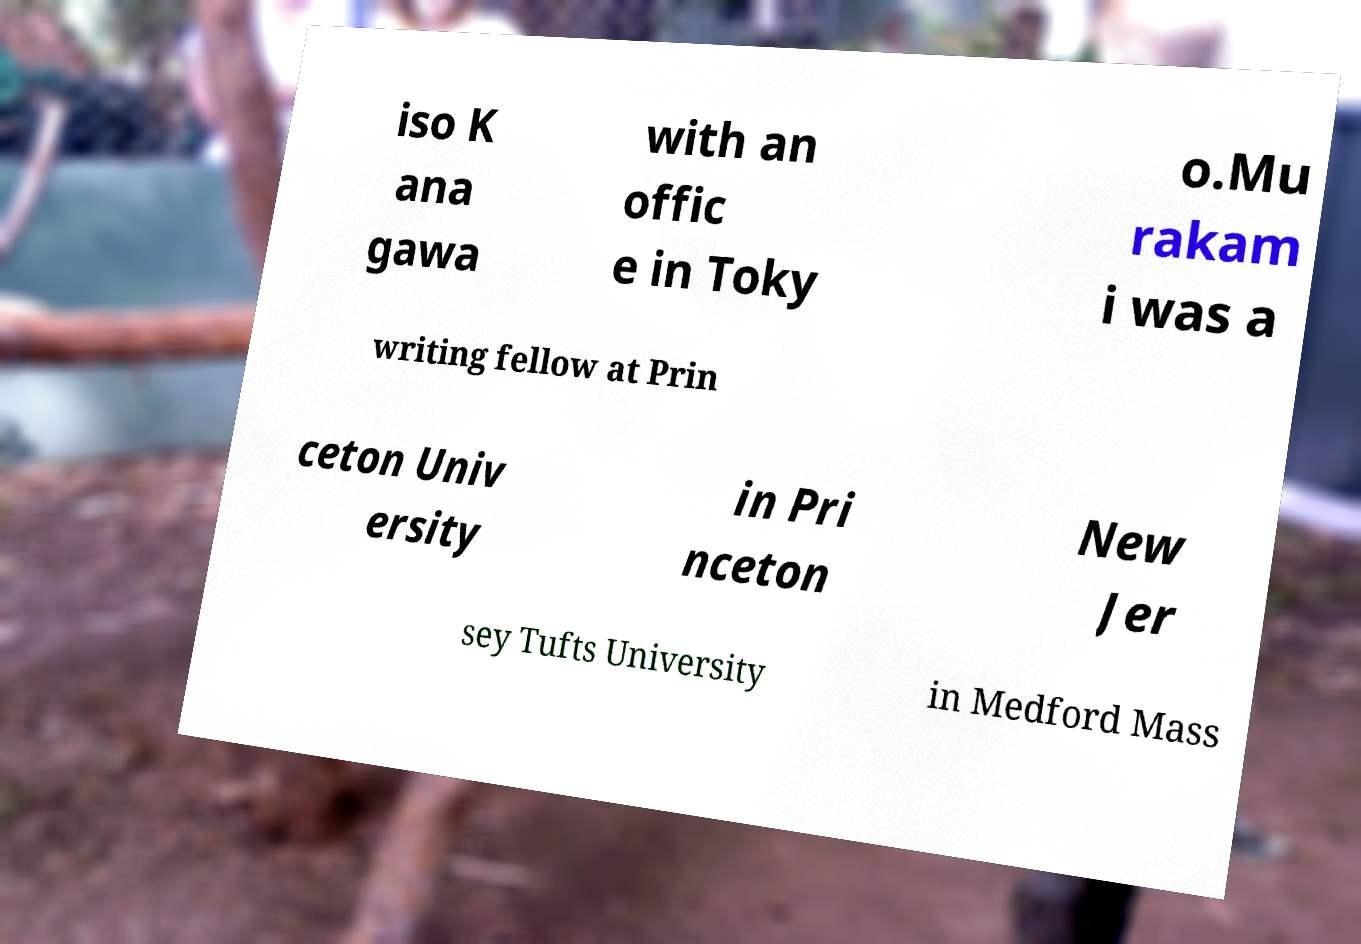What messages or text are displayed in this image? I need them in a readable, typed format. iso K ana gawa with an offic e in Toky o.Mu rakam i was a writing fellow at Prin ceton Univ ersity in Pri nceton New Jer sey Tufts University in Medford Mass 